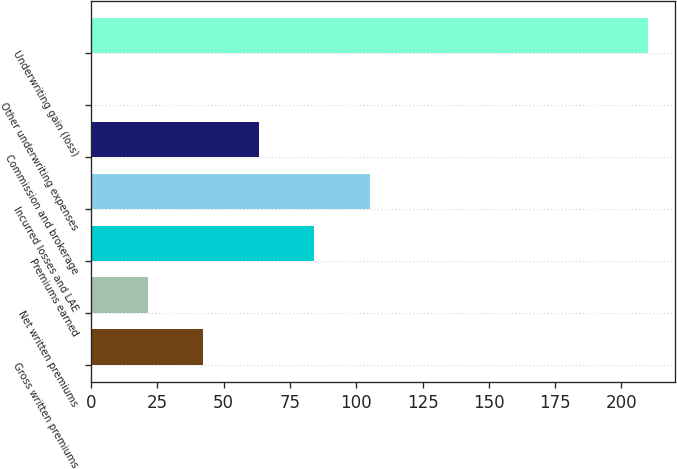Convert chart to OTSL. <chart><loc_0><loc_0><loc_500><loc_500><bar_chart><fcel>Gross written premiums<fcel>Net written premiums<fcel>Premiums earned<fcel>Incurred losses and LAE<fcel>Commission and brokerage<fcel>Other underwriting expenses<fcel>Underwriting gain (loss)<nl><fcel>42.38<fcel>21.44<fcel>84.26<fcel>105.2<fcel>63.32<fcel>0.5<fcel>209.9<nl></chart> 